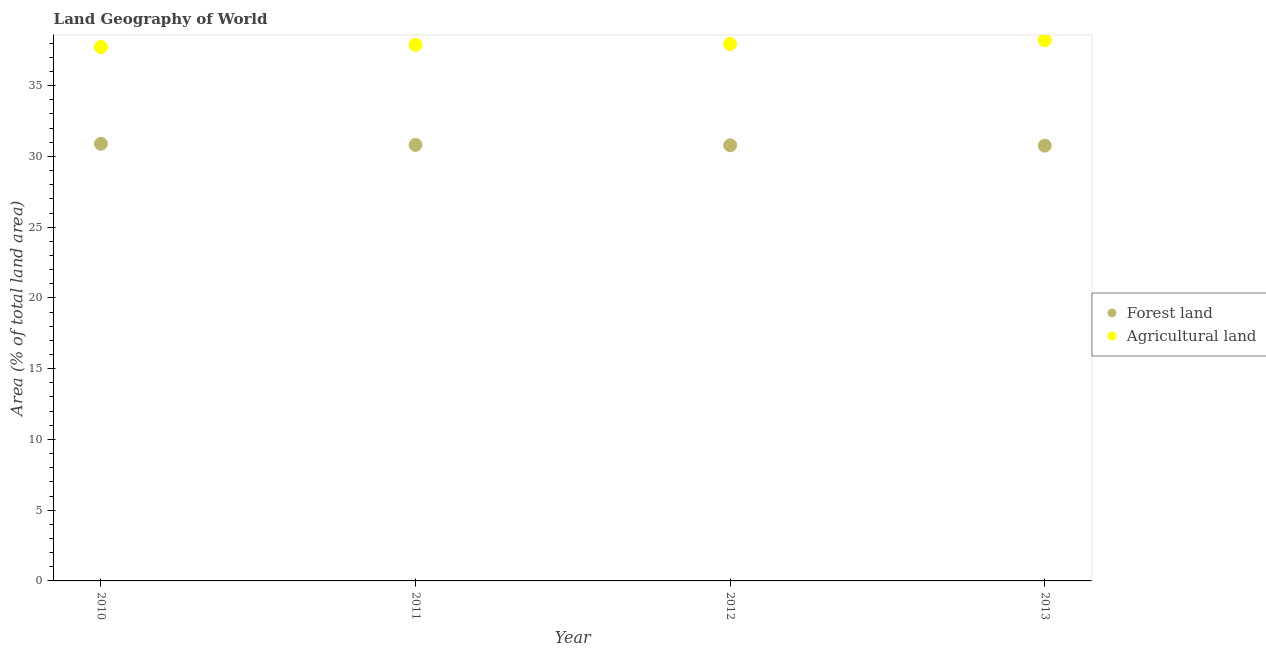How many different coloured dotlines are there?
Your answer should be compact. 2. What is the percentage of land area under forests in 2011?
Your answer should be compact. 30.81. Across all years, what is the maximum percentage of land area under forests?
Offer a very short reply. 30.89. Across all years, what is the minimum percentage of land area under forests?
Your response must be concise. 30.76. In which year was the percentage of land area under forests maximum?
Offer a terse response. 2010. What is the total percentage of land area under forests in the graph?
Offer a terse response. 123.25. What is the difference between the percentage of land area under agriculture in 2010 and that in 2013?
Offer a very short reply. -0.49. What is the difference between the percentage of land area under forests in 2011 and the percentage of land area under agriculture in 2010?
Keep it short and to the point. -6.92. What is the average percentage of land area under forests per year?
Your response must be concise. 30.81. In the year 2010, what is the difference between the percentage of land area under forests and percentage of land area under agriculture?
Ensure brevity in your answer.  -6.84. What is the ratio of the percentage of land area under forests in 2010 to that in 2012?
Offer a terse response. 1. Is the percentage of land area under forests in 2010 less than that in 2012?
Your answer should be very brief. No. Is the difference between the percentage of land area under forests in 2010 and 2013 greater than the difference between the percentage of land area under agriculture in 2010 and 2013?
Make the answer very short. Yes. What is the difference between the highest and the second highest percentage of land area under agriculture?
Your answer should be compact. 0.27. What is the difference between the highest and the lowest percentage of land area under agriculture?
Your answer should be compact. 0.49. Is the percentage of land area under forests strictly greater than the percentage of land area under agriculture over the years?
Ensure brevity in your answer.  No. How many dotlines are there?
Give a very brief answer. 2. How many years are there in the graph?
Your answer should be compact. 4. Does the graph contain any zero values?
Your answer should be compact. No. Does the graph contain grids?
Keep it short and to the point. No. Where does the legend appear in the graph?
Ensure brevity in your answer.  Center right. How many legend labels are there?
Offer a terse response. 2. What is the title of the graph?
Your answer should be very brief. Land Geography of World. Does "Research and Development" appear as one of the legend labels in the graph?
Provide a succinct answer. No. What is the label or title of the X-axis?
Offer a terse response. Year. What is the label or title of the Y-axis?
Ensure brevity in your answer.  Area (% of total land area). What is the Area (% of total land area) of Forest land in 2010?
Ensure brevity in your answer.  30.89. What is the Area (% of total land area) in Agricultural land in 2010?
Ensure brevity in your answer.  37.73. What is the Area (% of total land area) in Forest land in 2011?
Your answer should be very brief. 30.81. What is the Area (% of total land area) of Agricultural land in 2011?
Your answer should be very brief. 37.88. What is the Area (% of total land area) in Forest land in 2012?
Give a very brief answer. 30.79. What is the Area (% of total land area) of Agricultural land in 2012?
Your answer should be very brief. 37.95. What is the Area (% of total land area) of Forest land in 2013?
Keep it short and to the point. 30.76. What is the Area (% of total land area) in Agricultural land in 2013?
Give a very brief answer. 38.22. Across all years, what is the maximum Area (% of total land area) of Forest land?
Make the answer very short. 30.89. Across all years, what is the maximum Area (% of total land area) in Agricultural land?
Provide a short and direct response. 38.22. Across all years, what is the minimum Area (% of total land area) of Forest land?
Give a very brief answer. 30.76. Across all years, what is the minimum Area (% of total land area) in Agricultural land?
Keep it short and to the point. 37.73. What is the total Area (% of total land area) in Forest land in the graph?
Your answer should be very brief. 123.25. What is the total Area (% of total land area) in Agricultural land in the graph?
Make the answer very short. 151.78. What is the difference between the Area (% of total land area) in Forest land in 2010 and that in 2011?
Offer a terse response. 0.08. What is the difference between the Area (% of total land area) in Agricultural land in 2010 and that in 2011?
Offer a terse response. -0.15. What is the difference between the Area (% of total land area) of Forest land in 2010 and that in 2012?
Keep it short and to the point. 0.11. What is the difference between the Area (% of total land area) in Agricultural land in 2010 and that in 2012?
Your answer should be very brief. -0.22. What is the difference between the Area (% of total land area) in Forest land in 2010 and that in 2013?
Keep it short and to the point. 0.13. What is the difference between the Area (% of total land area) of Agricultural land in 2010 and that in 2013?
Offer a very short reply. -0.49. What is the difference between the Area (% of total land area) in Forest land in 2011 and that in 2012?
Provide a short and direct response. 0.02. What is the difference between the Area (% of total land area) of Agricultural land in 2011 and that in 2012?
Offer a very short reply. -0.07. What is the difference between the Area (% of total land area) of Forest land in 2011 and that in 2013?
Provide a succinct answer. 0.05. What is the difference between the Area (% of total land area) in Agricultural land in 2011 and that in 2013?
Provide a short and direct response. -0.34. What is the difference between the Area (% of total land area) of Forest land in 2012 and that in 2013?
Offer a very short reply. 0.03. What is the difference between the Area (% of total land area) of Agricultural land in 2012 and that in 2013?
Keep it short and to the point. -0.27. What is the difference between the Area (% of total land area) of Forest land in 2010 and the Area (% of total land area) of Agricultural land in 2011?
Give a very brief answer. -6.99. What is the difference between the Area (% of total land area) of Forest land in 2010 and the Area (% of total land area) of Agricultural land in 2012?
Provide a succinct answer. -7.05. What is the difference between the Area (% of total land area) of Forest land in 2010 and the Area (% of total land area) of Agricultural land in 2013?
Give a very brief answer. -7.32. What is the difference between the Area (% of total land area) of Forest land in 2011 and the Area (% of total land area) of Agricultural land in 2012?
Provide a short and direct response. -7.14. What is the difference between the Area (% of total land area) in Forest land in 2011 and the Area (% of total land area) in Agricultural land in 2013?
Ensure brevity in your answer.  -7.4. What is the difference between the Area (% of total land area) of Forest land in 2012 and the Area (% of total land area) of Agricultural land in 2013?
Your answer should be compact. -7.43. What is the average Area (% of total land area) of Forest land per year?
Provide a succinct answer. 30.81. What is the average Area (% of total land area) in Agricultural land per year?
Offer a very short reply. 37.94. In the year 2010, what is the difference between the Area (% of total land area) in Forest land and Area (% of total land area) in Agricultural land?
Make the answer very short. -6.84. In the year 2011, what is the difference between the Area (% of total land area) of Forest land and Area (% of total land area) of Agricultural land?
Give a very brief answer. -7.07. In the year 2012, what is the difference between the Area (% of total land area) of Forest land and Area (% of total land area) of Agricultural land?
Make the answer very short. -7.16. In the year 2013, what is the difference between the Area (% of total land area) in Forest land and Area (% of total land area) in Agricultural land?
Your answer should be very brief. -7.45. What is the ratio of the Area (% of total land area) in Agricultural land in 2010 to that in 2012?
Give a very brief answer. 0.99. What is the ratio of the Area (% of total land area) of Forest land in 2010 to that in 2013?
Offer a very short reply. 1. What is the ratio of the Area (% of total land area) of Agricultural land in 2010 to that in 2013?
Provide a succinct answer. 0.99. What is the ratio of the Area (% of total land area) in Agricultural land in 2011 to that in 2012?
Offer a terse response. 1. What is the ratio of the Area (% of total land area) of Agricultural land in 2011 to that in 2013?
Make the answer very short. 0.99. What is the ratio of the Area (% of total land area) of Forest land in 2012 to that in 2013?
Your answer should be compact. 1. What is the difference between the highest and the second highest Area (% of total land area) of Forest land?
Give a very brief answer. 0.08. What is the difference between the highest and the second highest Area (% of total land area) in Agricultural land?
Offer a very short reply. 0.27. What is the difference between the highest and the lowest Area (% of total land area) in Forest land?
Ensure brevity in your answer.  0.13. What is the difference between the highest and the lowest Area (% of total land area) of Agricultural land?
Make the answer very short. 0.49. 